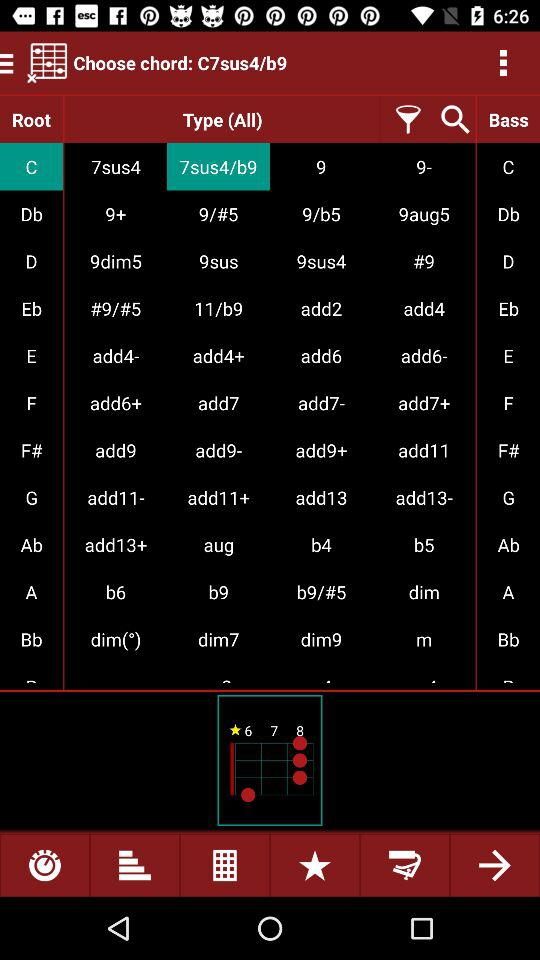What is the application name? The application name is "Choose chord: C7sus4/b9". 